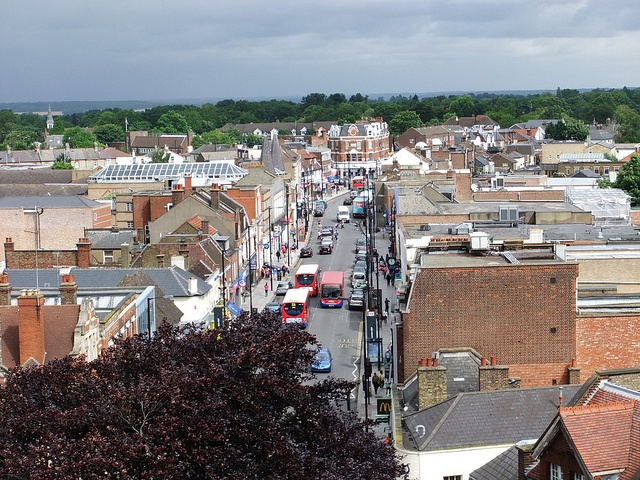Describe the objects in this image and their specific colors. I can see car in darkgray, lightgray, gray, and black tones, people in darkgray, black, gray, and lightgray tones, bus in darkgray, white, black, gray, and red tones, bus in darkgray, lightpink, black, gray, and navy tones, and bus in darkgray, white, black, gray, and maroon tones in this image. 